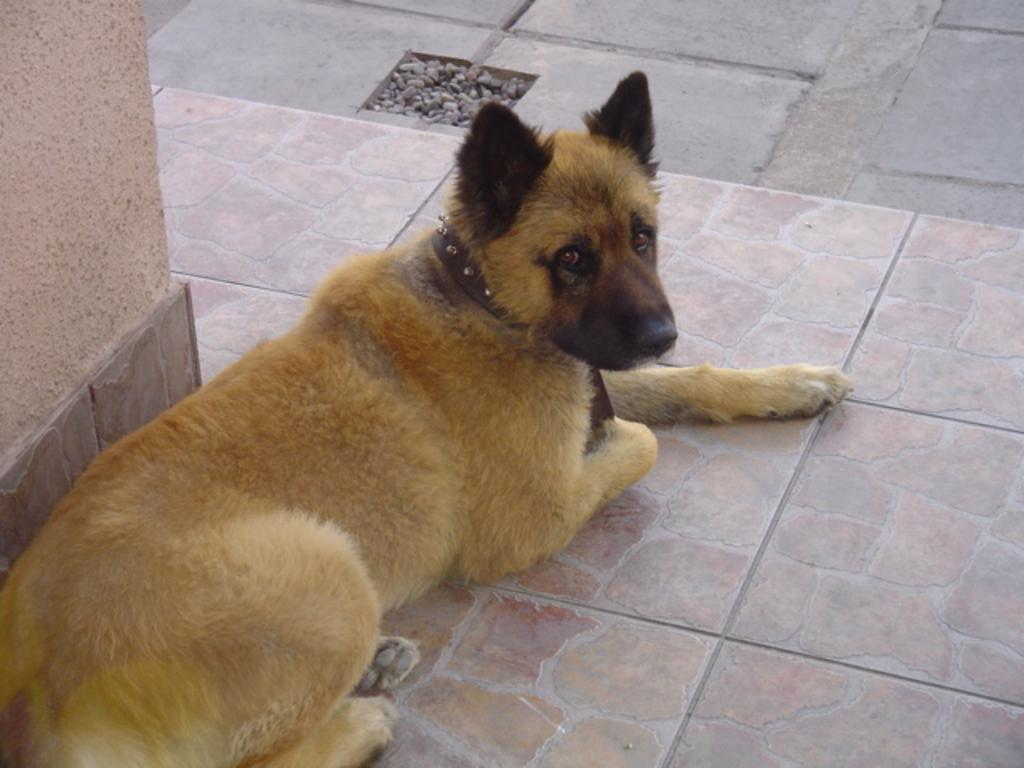What is the main subject in the center of the image? There is a dog in the center of the image. What type of surface is visible beneath the dog? There is a floor visible in the image. What architectural feature can be seen on the left side of the image? There is a pillar on the left side of the image. How many boys are playing with the ladybug in the image? There are no boys or ladybugs present in the image. 